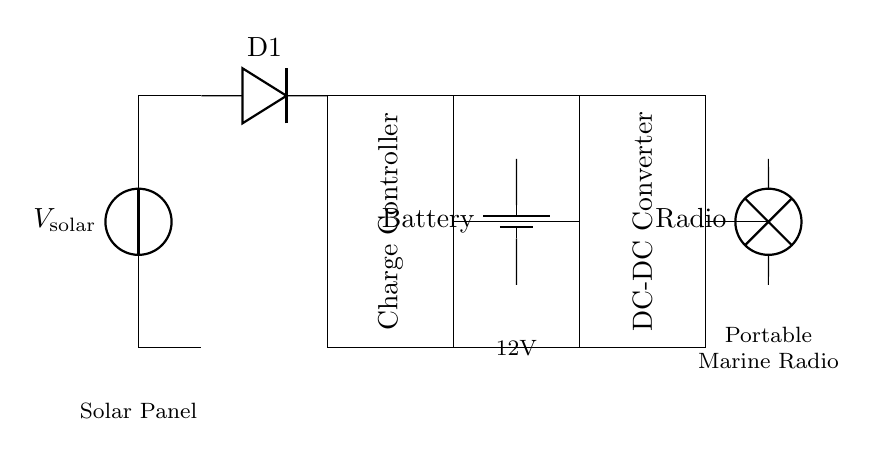What type of power source is used in this circuit? The circuit uses a solar power source as indicated by the solar panel component labeled V_solar.
Answer: Solar power What is the function of the diode in this circuit? The diode (D1) is used to prevent reverse current flow, ensuring that the energy generated from the solar panel only flows in one direction towards the charge controller and battery.
Answer: Prevent reverse current What component converts the battery's voltage? The DC-DC converter converts the battery's voltage to a suitable level for the load, which is the portable marine radio located at the end of the circuit.
Answer: DC-DC converter What is the voltage supplied to the battery? The voltage supplied to the battery is specified as 12V within the circuit, indicating the output voltage from the charge controller.
Answer: 12V Explain the purpose of the charge controller in this circuit. The charge controller regulates the voltage and current coming from the solar panel to the battery, preventing overcharging and ensuring the battery is charged efficiently. This is crucial for maintaining battery health and optimizing performance.
Answer: Regulate charging How is the energy flow directed from the solar panel to the load? Energy flows from the solar panel to the charge controller, which sends the energy to the battery for storage. The stored energy can then be converted by the DC-DC converter before reaching the portable marine radio. Thus, the sequence of components shows a clear path for energy from generation to use.
Answer: Solar panel to charge controller to battery to DC-DC converter to load 